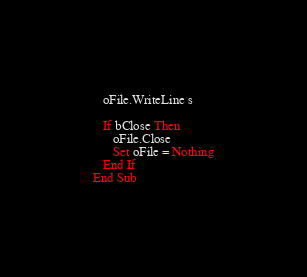Convert code to text. <code><loc_0><loc_0><loc_500><loc_500><_VisualBasic_>
   oFile.WriteLine s

   If bClose Then
      oFile.Close
      Set oFile = Nothing
   End If
End Sub
</code> 